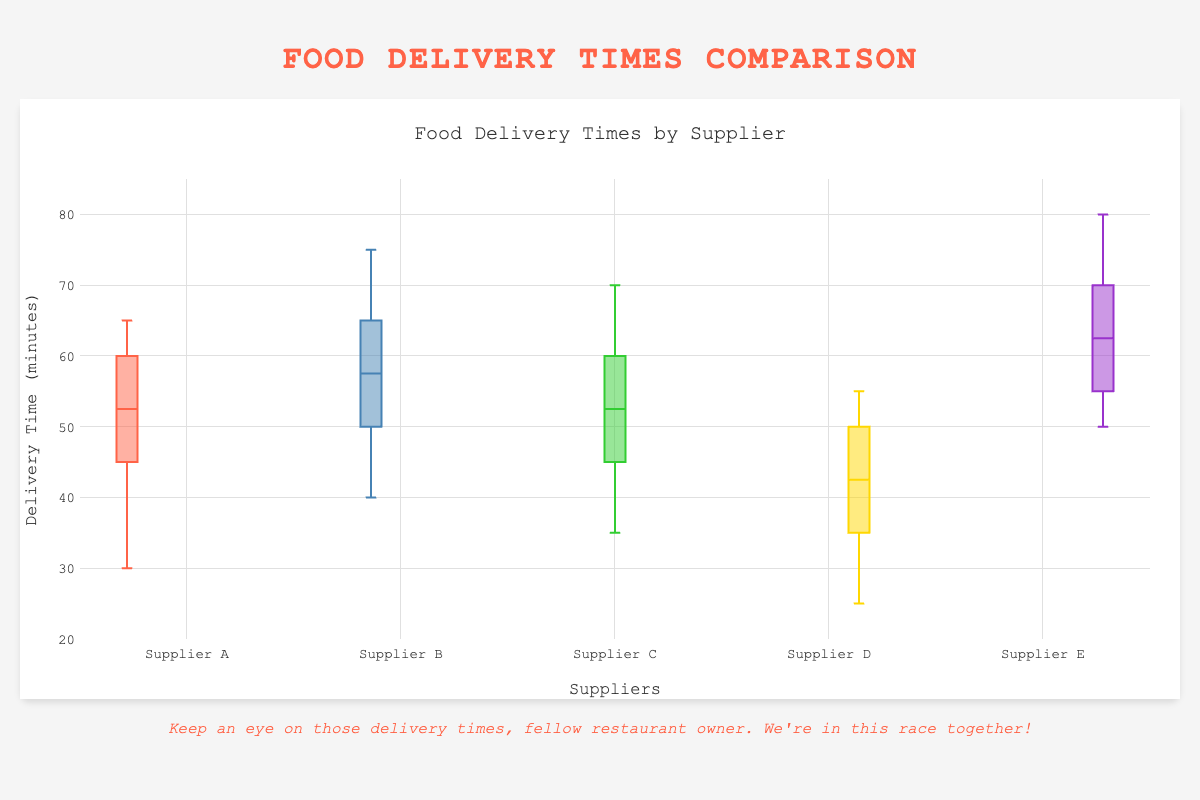which supplier has the lowest median delivery time? Supplier D has the lowest median delivery time because its median line is positioned lower on the y-axis compared to other suppliers.
Answer: Supplier D what is the title of the plot? The title is prominently displayed at the top of the plot and states the main topic it represents.
Answer: Food Delivery Times by Supplier which supplier shows the most consistency in delivery times? Supplier D shows the most consistency as its box is the smallest, indicating less variation in delivery times.
Answer: Supplier D which suppliers have delivery times above 70 minutes? The box plots for Supplier B and Supplier E extend above the 70-minute mark, indicating some delivery times in that range.
Answer: Supplier B and Supplier E how does supplier A compare with supplier C in terms of median delivery time? By looking at the median lines in their respective boxes, we see that Supplier A and Supplier C have similar median delivery times, around 55 minutes.
Answer: Similar what's the range of delivery times for supplier E? The range is calculated by subtracting the minimum value (50) from the maximum value (80). The whiskers extend to 50 and 80.
Answer: 30 minutes what does the y-axis represent? The y-axis represents the delivery time in minutes.
Answer: Delivery time in minutes which supplier has the widest range of delivery times? Supplier E has the widest range, as indicated by the length of its whiskers from around 50 to 80 minutes.
Answer: Supplier E what is the color of supplier C's box plot? The color of Supplier C's box plot is green.
Answer: Green which supplier has its interquartile range (IQR) between 40 and 50 minutes? Supplier D has an IQR between 40 and 50 minutes, indicated by the lower and upper bounds of its box.
Answer: Supplier D 